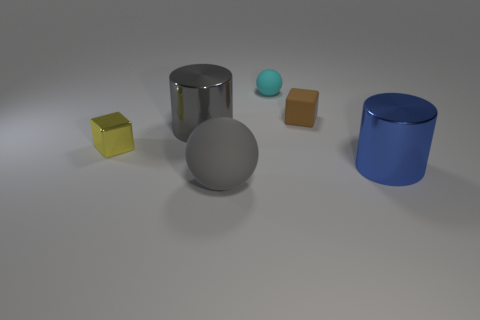Subtract all cyan spheres. How many spheres are left? 1 Subtract all spheres. How many objects are left? 4 Subtract 1 balls. How many balls are left? 1 Subtract all blue balls. How many blue cylinders are left? 1 Add 1 large gray cylinders. How many objects exist? 7 Subtract 0 green cylinders. How many objects are left? 6 Subtract all green spheres. Subtract all red cylinders. How many spheres are left? 2 Subtract all blue cylinders. Subtract all tiny yellow metallic cubes. How many objects are left? 4 Add 3 brown objects. How many brown objects are left? 4 Add 3 blue shiny objects. How many blue shiny objects exist? 4 